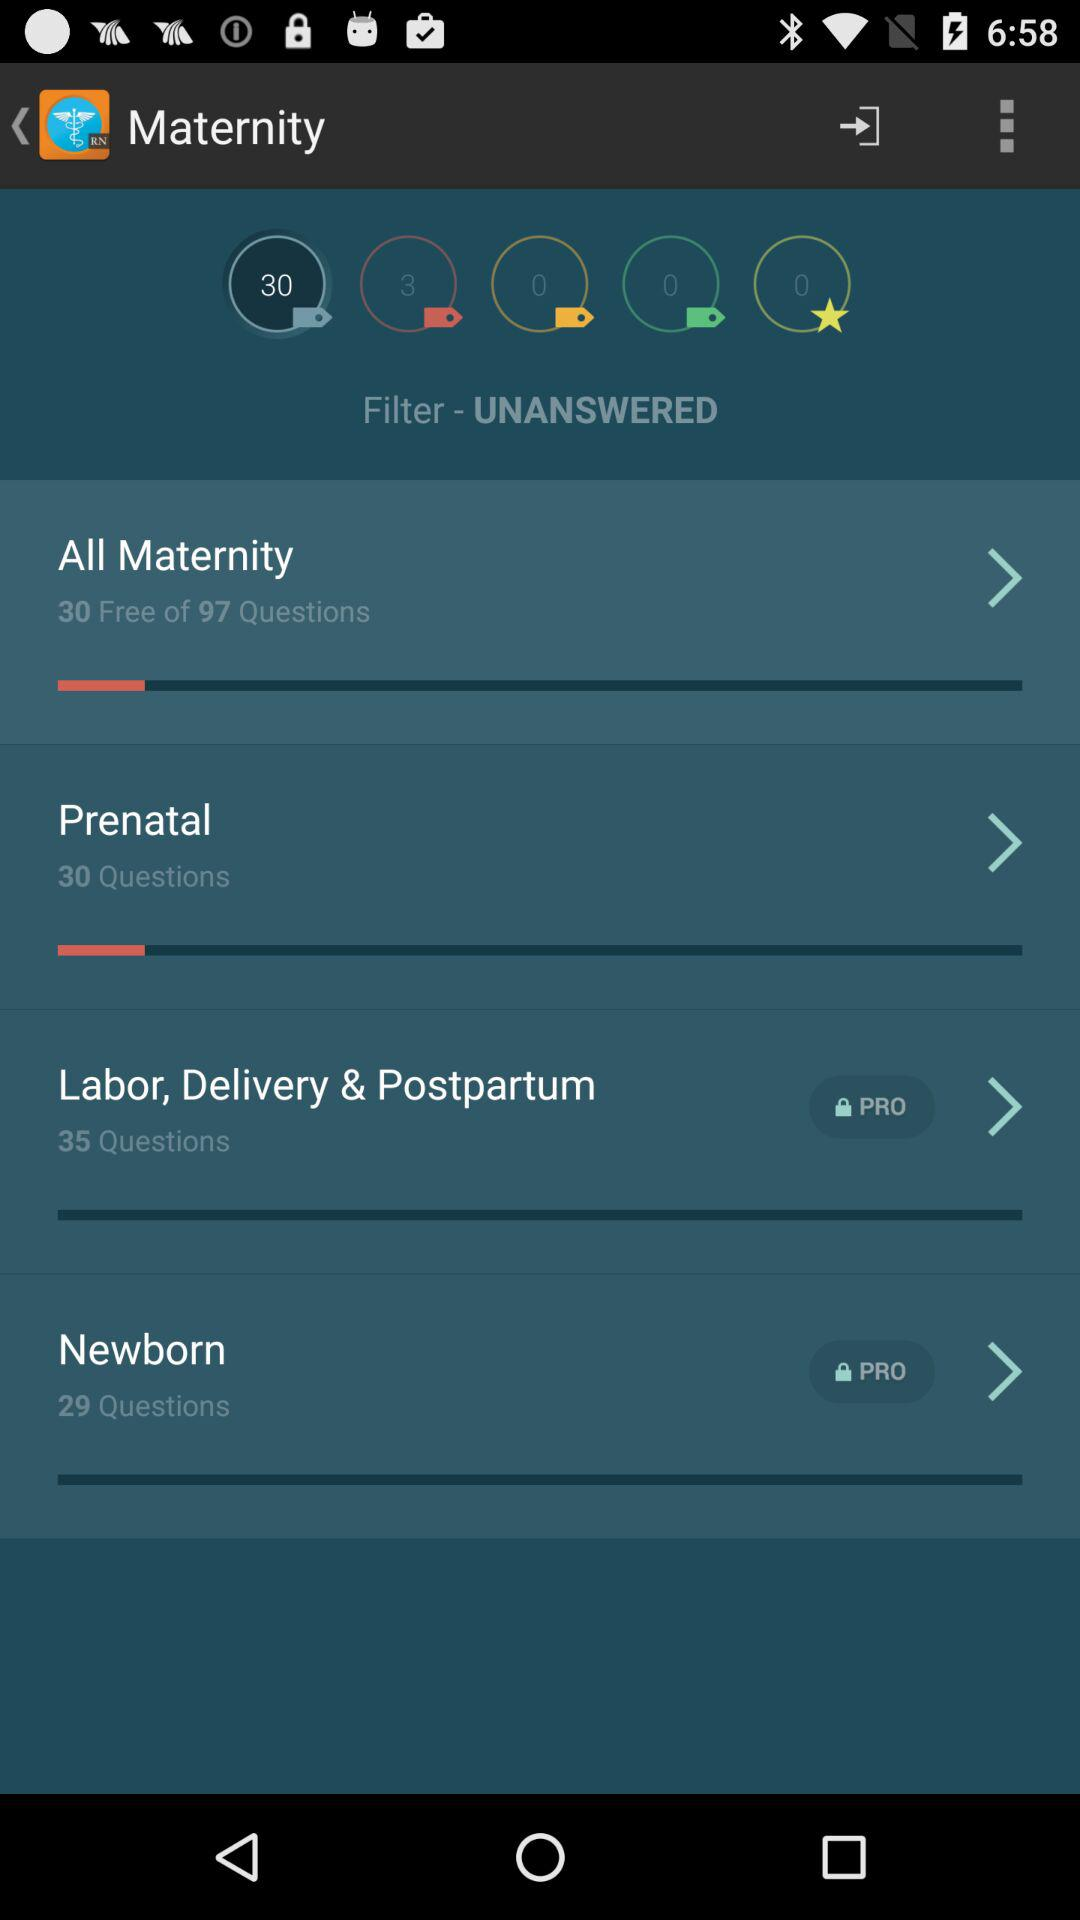How many more questions are there in the Labor, Delivery & Postpartum section than in the Newborn section?
Answer the question using a single word or phrase. 6 